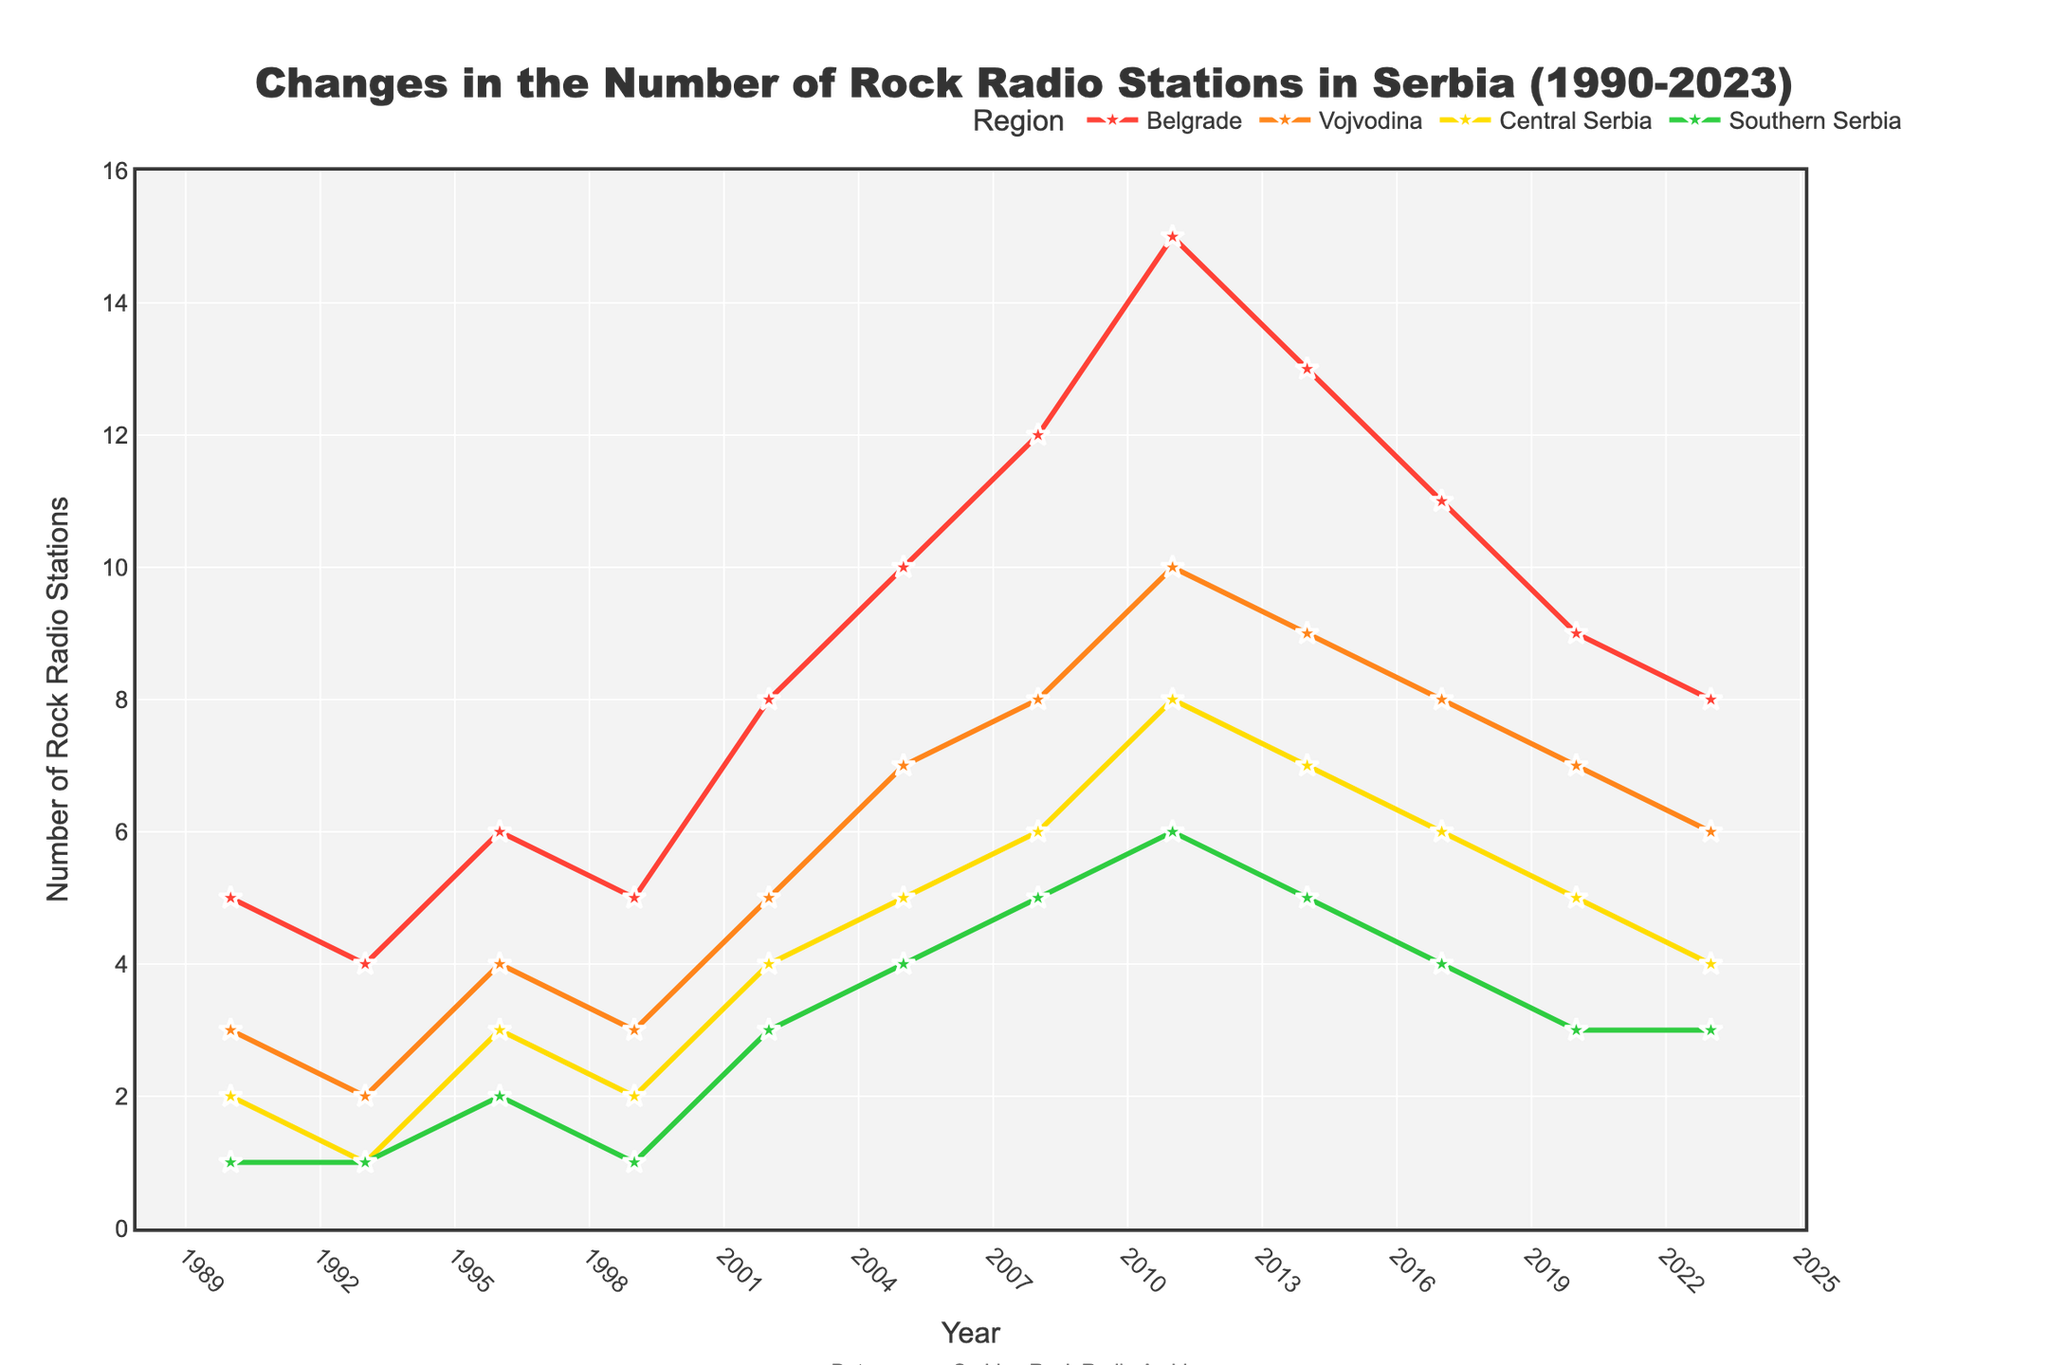How many rock radio stations were there in Belgrade in 2008? Look at the line corresponding to Belgrade and find the y-axis value in 2008.
Answer: 12 Which region had the highest number of rock radio stations in 2011? Compare the y-axis values for all regions in 2011. The highest value is for Belgrade.
Answer: Belgrade Between which years did Southern Serbia see the highest increase in rock radio stations? Look at the changes in the number of stations in Southern Serbia over time. The largest increase is between 2005 and 2008, from 4 to 5 stations respectively.
Answer: 2005-2008 In which year did Central Serbia have 5 rock radio stations? Find the year on the x-axis where the Central Serbia line (yellow) intersects the y-axis value of 5.
Answer: 2005 How many more rock radio stations were there in Vojvodina compared to Southern Serbia in 2023? Subtract the value for Southern Serbia from the value for Vojvodina in 2023. 6 (Vojvodina) - 3 (Southern Serbia) = 3.
Answer: 3 Which region experienced the most significant decline from 2017 to 2023? Calculate the difference in number of stations for each region between 2017 and 2023 and identify the largest drop. Belgrade had the largest decline from 11 to 8 stations.
Answer: Belgrade From 1996 to 1999, what was the trend in the number of rock radio stations for Central Serbia? Observe the line for Central Serbia (yellow) between 1996 and 1999, which shows a decrease from 3 to 2 stations.
Answer: Decreasing How many regions had more than 5 rock radio stations in 2014? Count the number of regions above the 5-station mark for the year 2014. Both Belgrade (13), Vojvodina (9), and Central Serbia (7) cross this threshold.
Answer: 3 By how much did the number of rock radio stations in Belgrade increase from 1999 to 2002? Compare the number of stations in Belgrade for the years 1999 and 2002. The increase is from 5 to 8 stations, which is 8 - 5 = 3.
Answer: 3 What was the average number of rock radio stations in Southern Serbia over the reported years? Sum the values for Southern Serbia and divide by the number of years. (1+1+2+1+3+4+5+6+5+4+3+3)/12 = 3.
Answer: 3 